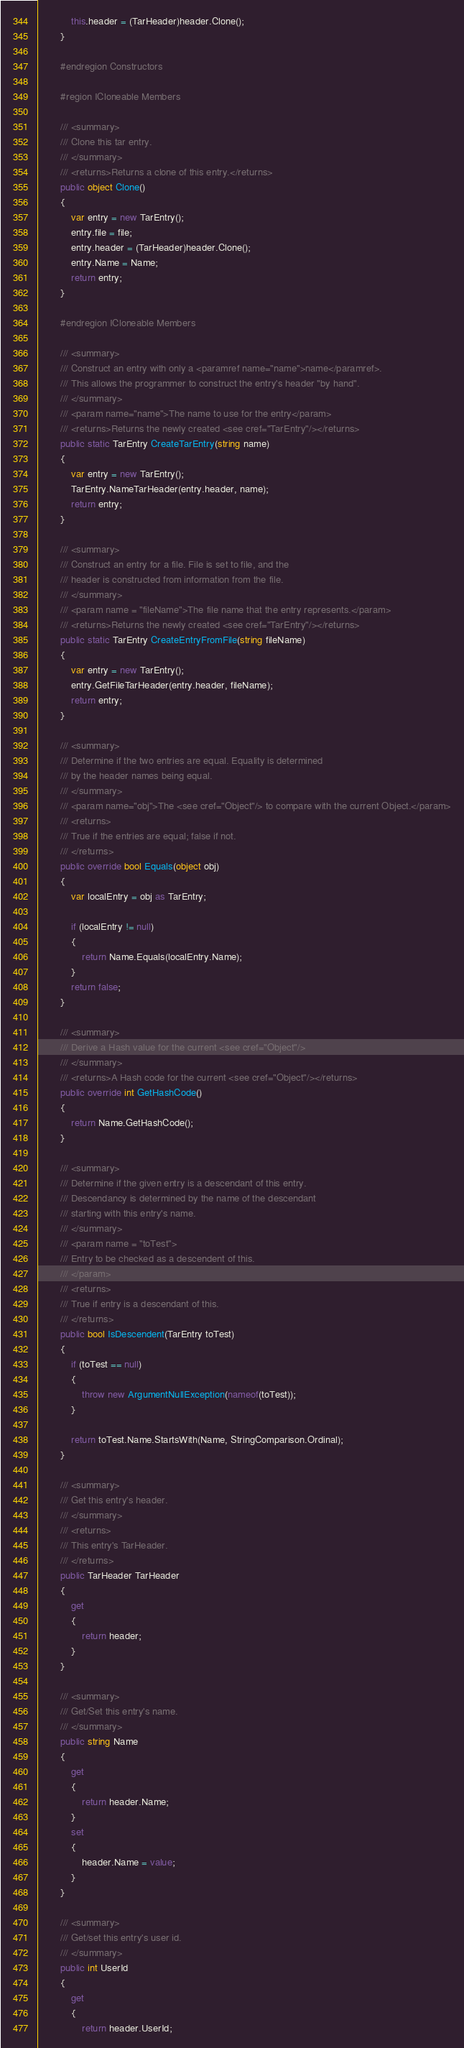<code> <loc_0><loc_0><loc_500><loc_500><_C#_>			this.header = (TarHeader)header.Clone();
		}

		#endregion Constructors

		#region ICloneable Members

		/// <summary>
		/// Clone this tar entry.
		/// </summary>
		/// <returns>Returns a clone of this entry.</returns>
		public object Clone()
		{
			var entry = new TarEntry();
			entry.file = file;
			entry.header = (TarHeader)header.Clone();
			entry.Name = Name;
			return entry;
		}

		#endregion ICloneable Members

		/// <summary>
		/// Construct an entry with only a <paramref name="name">name</paramref>.
		/// This allows the programmer to construct the entry's header "by hand".
		/// </summary>
		/// <param name="name">The name to use for the entry</param>
		/// <returns>Returns the newly created <see cref="TarEntry"/></returns>
		public static TarEntry CreateTarEntry(string name)
		{
			var entry = new TarEntry();
			TarEntry.NameTarHeader(entry.header, name);
			return entry;
		}

		/// <summary>
		/// Construct an entry for a file. File is set to file, and the
		/// header is constructed from information from the file.
		/// </summary>
		/// <param name = "fileName">The file name that the entry represents.</param>
		/// <returns>Returns the newly created <see cref="TarEntry"/></returns>
		public static TarEntry CreateEntryFromFile(string fileName)
		{
			var entry = new TarEntry();
			entry.GetFileTarHeader(entry.header, fileName);
			return entry;
		}

		/// <summary>
		/// Determine if the two entries are equal. Equality is determined
		/// by the header names being equal.
		/// </summary>
		/// <param name="obj">The <see cref="Object"/> to compare with the current Object.</param>
		/// <returns>
		/// True if the entries are equal; false if not.
		/// </returns>
		public override bool Equals(object obj)
		{
			var localEntry = obj as TarEntry;

			if (localEntry != null)
			{
				return Name.Equals(localEntry.Name);
			}
			return false;
		}

		/// <summary>
		/// Derive a Hash value for the current <see cref="Object"/>
		/// </summary>
		/// <returns>A Hash code for the current <see cref="Object"/></returns>
		public override int GetHashCode()
		{
			return Name.GetHashCode();
		}

		/// <summary>
		/// Determine if the given entry is a descendant of this entry.
		/// Descendancy is determined by the name of the descendant
		/// starting with this entry's name.
		/// </summary>
		/// <param name = "toTest">
		/// Entry to be checked as a descendent of this.
		/// </param>
		/// <returns>
		/// True if entry is a descendant of this.
		/// </returns>
		public bool IsDescendent(TarEntry toTest)
		{
			if (toTest == null)
			{
				throw new ArgumentNullException(nameof(toTest));
			}

			return toTest.Name.StartsWith(Name, StringComparison.Ordinal);
		}

		/// <summary>
		/// Get this entry's header.
		/// </summary>
		/// <returns>
		/// This entry's TarHeader.
		/// </returns>
		public TarHeader TarHeader
		{
			get
			{
				return header;
			}
		}

		/// <summary>
		/// Get/Set this entry's name.
		/// </summary>
		public string Name
		{
			get
			{
				return header.Name;
			}
			set
			{
				header.Name = value;
			}
		}

		/// <summary>
		/// Get/set this entry's user id.
		/// </summary>
		public int UserId
		{
			get
			{
				return header.UserId;</code> 